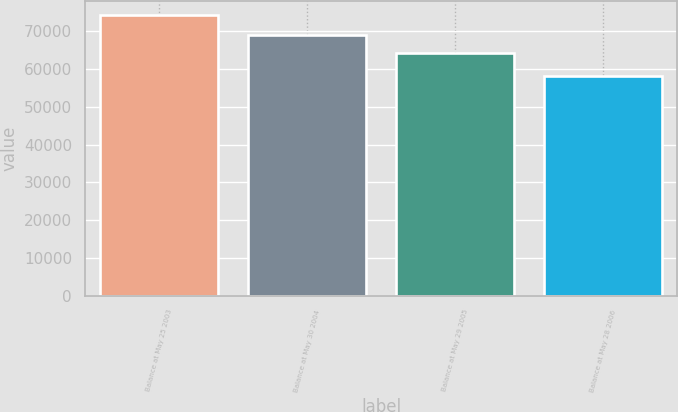Convert chart. <chart><loc_0><loc_0><loc_500><loc_500><bar_chart><fcel>Balance at May 25 2003<fcel>Balance at May 30 2004<fcel>Balance at May 29 2005<fcel>Balance at May 28 2006<nl><fcel>74360<fcel>69113<fcel>64259<fcel>58203<nl></chart> 